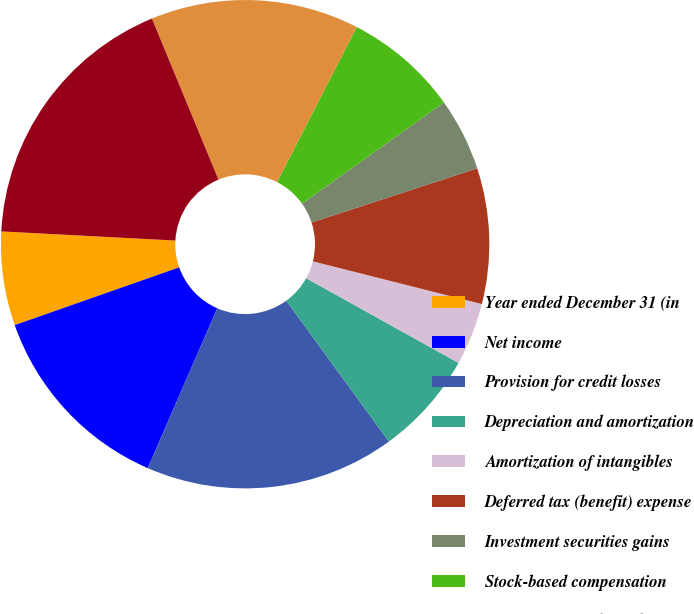Convert chart. <chart><loc_0><loc_0><loc_500><loc_500><pie_chart><fcel>Year ended December 31 (in<fcel>Net income<fcel>Provision for credit losses<fcel>Depreciation and amortization<fcel>Amortization of intangibles<fcel>Deferred tax (benefit) expense<fcel>Investment securities gains<fcel>Stock-based compensation<fcel>Originations and purchases of<fcel>Proceeds from sales<nl><fcel>6.21%<fcel>13.1%<fcel>16.55%<fcel>6.9%<fcel>4.14%<fcel>8.97%<fcel>4.83%<fcel>7.59%<fcel>13.79%<fcel>17.93%<nl></chart> 